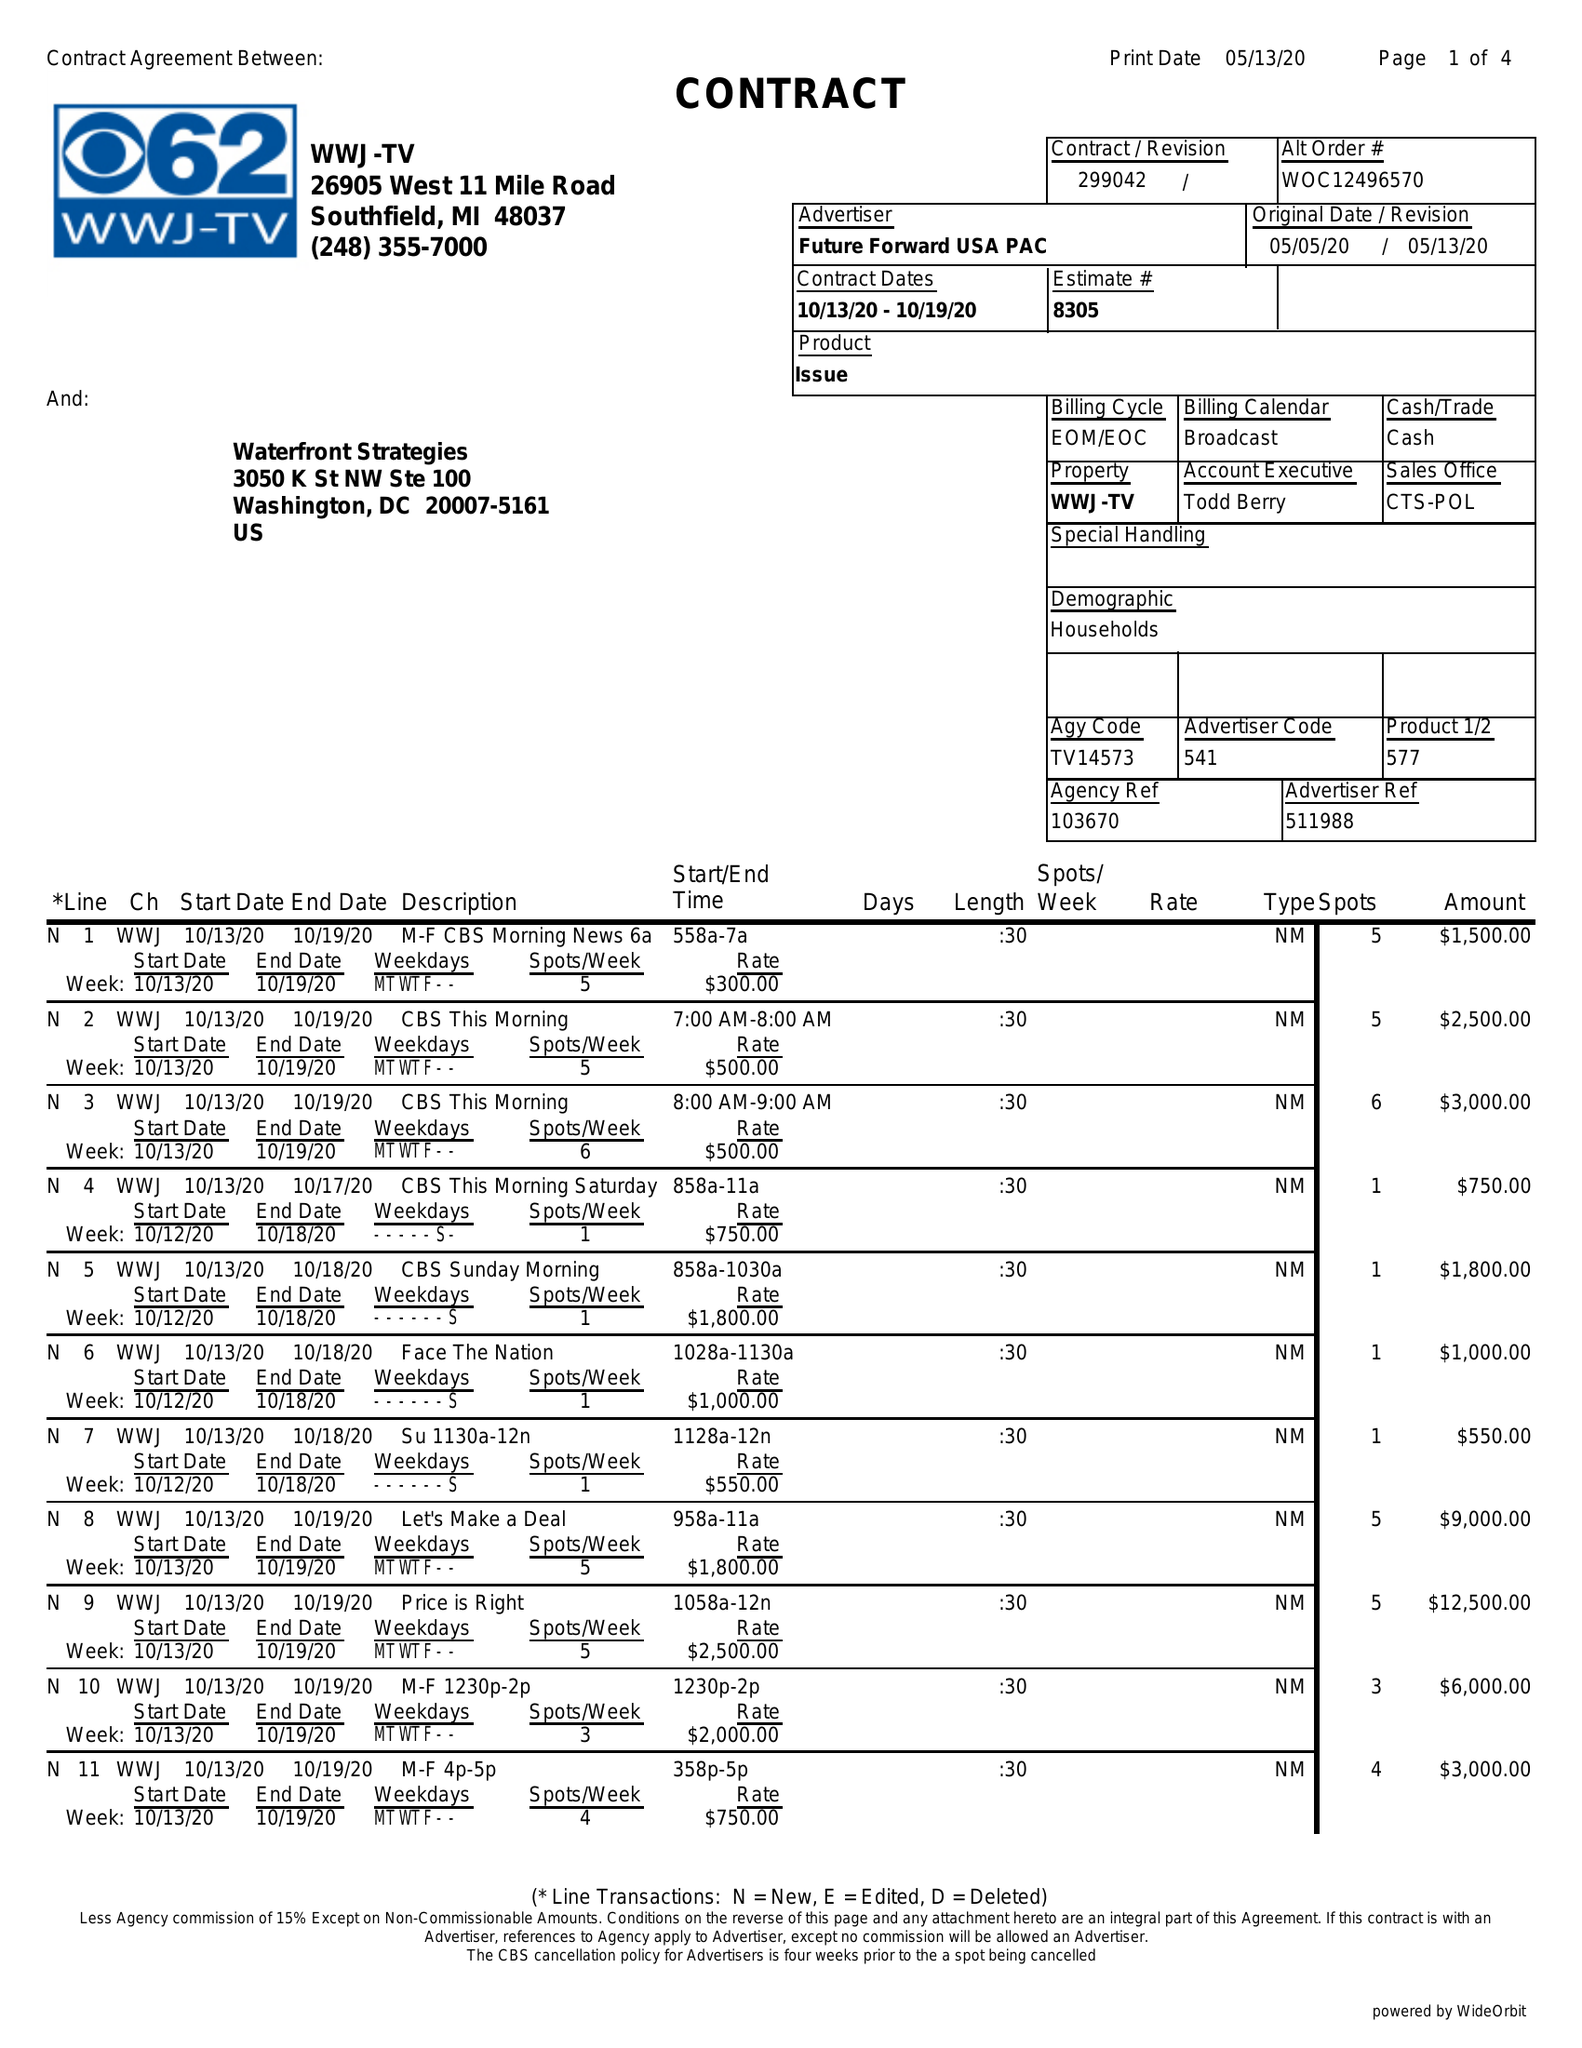What is the value for the flight_from?
Answer the question using a single word or phrase. 10/13/20 